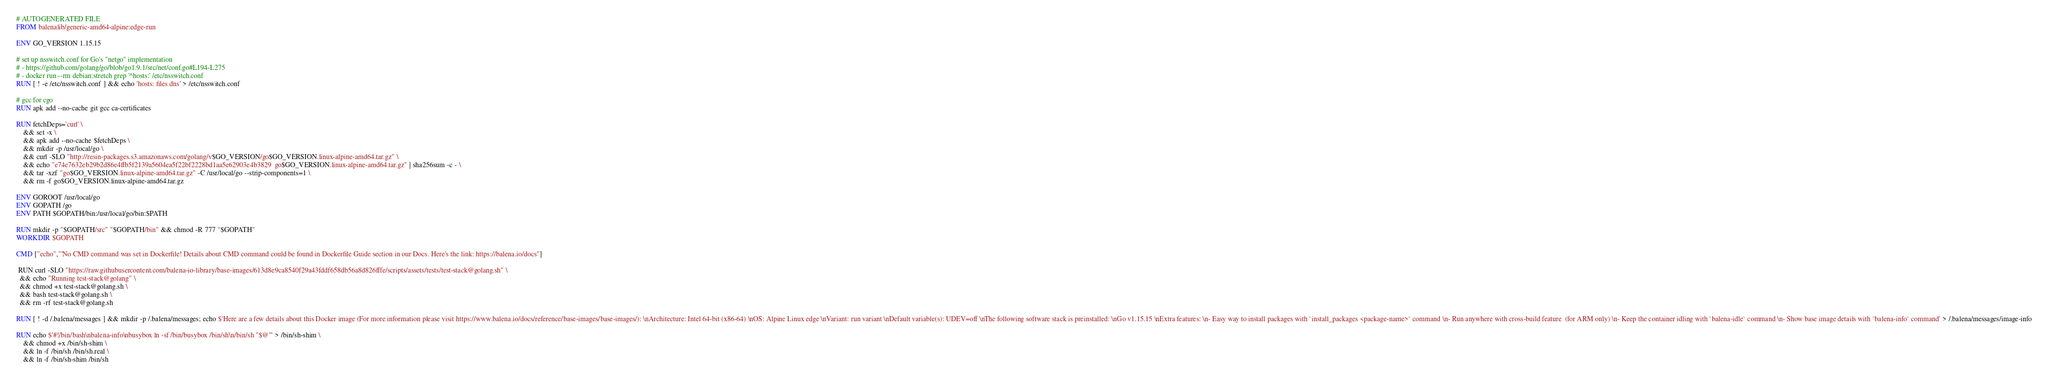Convert code to text. <code><loc_0><loc_0><loc_500><loc_500><_Dockerfile_># AUTOGENERATED FILE
FROM balenalib/generic-amd64-alpine:edge-run

ENV GO_VERSION 1.15.15

# set up nsswitch.conf for Go's "netgo" implementation
# - https://github.com/golang/go/blob/go1.9.1/src/net/conf.go#L194-L275
# - docker run --rm debian:stretch grep '^hosts:' /etc/nsswitch.conf
RUN [ ! -e /etc/nsswitch.conf ] && echo 'hosts: files dns' > /etc/nsswitch.conf

# gcc for cgo
RUN apk add --no-cache git gcc ca-certificates

RUN fetchDeps='curl' \
	&& set -x \
	&& apk add --no-cache $fetchDeps \
	&& mkdir -p /usr/local/go \
	&& curl -SLO "http://resin-packages.s3.amazonaws.com/golang/v$GO_VERSION/go$GO_VERSION.linux-alpine-amd64.tar.gz" \
	&& echo "e74e7632eb29b2d86e4ffb5f2139a5604ea5f22bf2228bd1aa5e62903e4b3829  go$GO_VERSION.linux-alpine-amd64.tar.gz" | sha256sum -c - \
	&& tar -xzf "go$GO_VERSION.linux-alpine-amd64.tar.gz" -C /usr/local/go --strip-components=1 \
	&& rm -f go$GO_VERSION.linux-alpine-amd64.tar.gz

ENV GOROOT /usr/local/go
ENV GOPATH /go
ENV PATH $GOPATH/bin:/usr/local/go/bin:$PATH

RUN mkdir -p "$GOPATH/src" "$GOPATH/bin" && chmod -R 777 "$GOPATH"
WORKDIR $GOPATH

CMD ["echo","'No CMD command was set in Dockerfile! Details about CMD command could be found in Dockerfile Guide section in our Docs. Here's the link: https://balena.io/docs"]

 RUN curl -SLO "https://raw.githubusercontent.com/balena-io-library/base-images/613d8e9ca8540f29a43fddf658db56a8d826fffe/scripts/assets/tests/test-stack@golang.sh" \
  && echo "Running test-stack@golang" \
  && chmod +x test-stack@golang.sh \
  && bash test-stack@golang.sh \
  && rm -rf test-stack@golang.sh 

RUN [ ! -d /.balena/messages ] && mkdir -p /.balena/messages; echo $'Here are a few details about this Docker image (For more information please visit https://www.balena.io/docs/reference/base-images/base-images/): \nArchitecture: Intel 64-bit (x86-64) \nOS: Alpine Linux edge \nVariant: run variant \nDefault variable(s): UDEV=off \nThe following software stack is preinstalled: \nGo v1.15.15 \nExtra features: \n- Easy way to install packages with `install_packages <package-name>` command \n- Run anywhere with cross-build feature  (for ARM only) \n- Keep the container idling with `balena-idle` command \n- Show base image details with `balena-info` command' > /.balena/messages/image-info

RUN echo $'#!/bin/bash\nbalena-info\nbusybox ln -sf /bin/busybox /bin/sh\n/bin/sh "$@"' > /bin/sh-shim \
	&& chmod +x /bin/sh-shim \
	&& ln -f /bin/sh /bin/sh.real \
	&& ln -f /bin/sh-shim /bin/sh</code> 